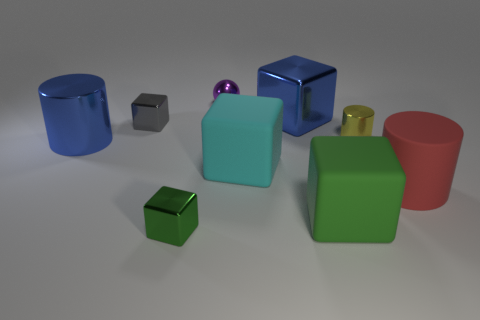How many objects are either things in front of the metal ball or blue cubes? In the image, there are nine objects present. Excluding the metal ball placed centrally towards the back, there are two objects in front of it: a smaller cube and a larger cube. Alongside these, there are two blue cubes in the image. Therefore, in total, there are four objects that meet the criteria of being either in front of the metal ball or being blue cubes. 